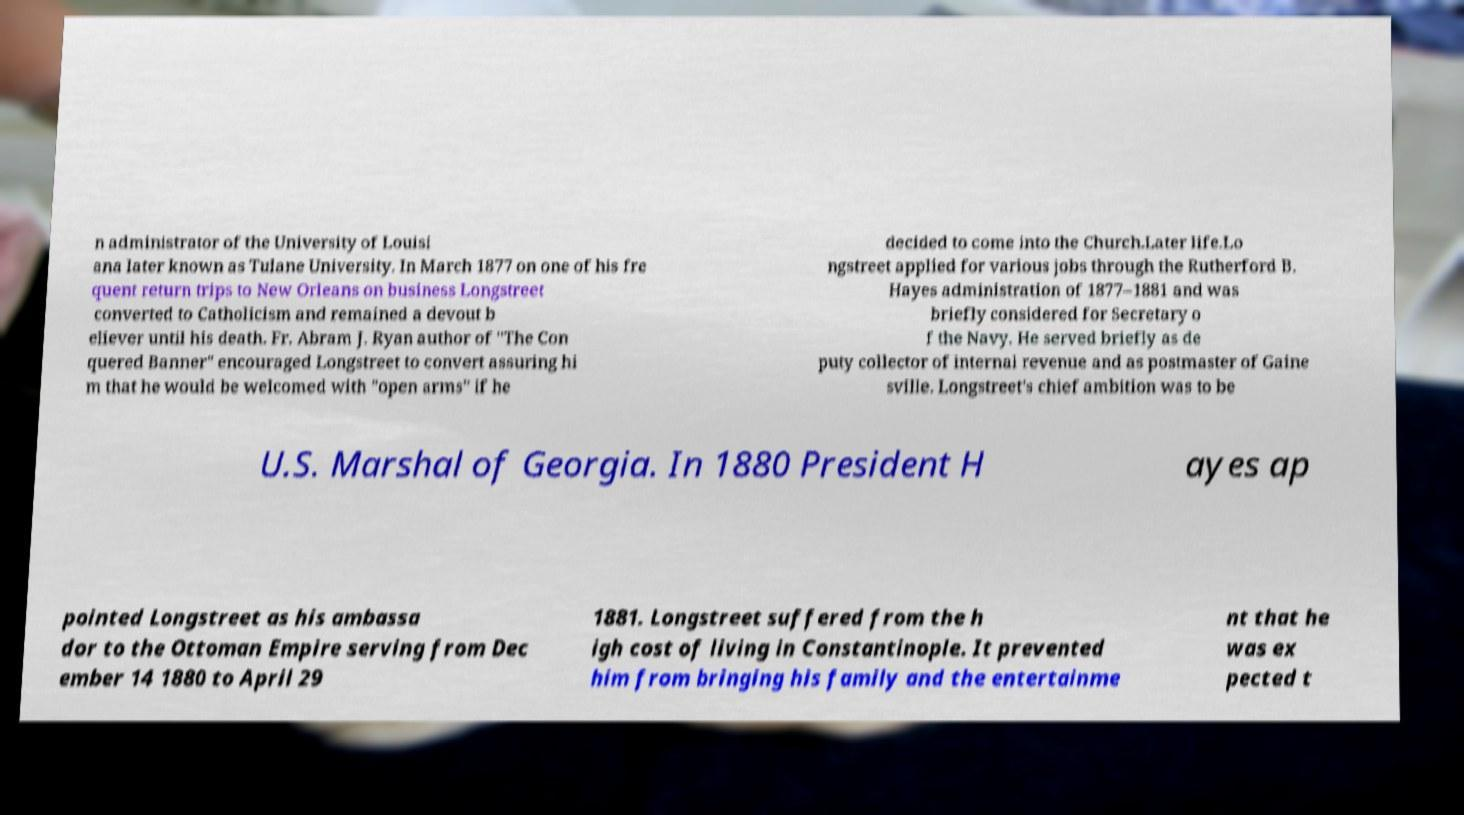What messages or text are displayed in this image? I need them in a readable, typed format. n administrator of the University of Louisi ana later known as Tulane University. In March 1877 on one of his fre quent return trips to New Orleans on business Longstreet converted to Catholicism and remained a devout b eliever until his death. Fr. Abram J. Ryan author of "The Con quered Banner" encouraged Longstreet to convert assuring hi m that he would be welcomed with "open arms" if he decided to come into the Church.Later life.Lo ngstreet applied for various jobs through the Rutherford B. Hayes administration of 1877–1881 and was briefly considered for Secretary o f the Navy. He served briefly as de puty collector of internal revenue and as postmaster of Gaine sville. Longstreet's chief ambition was to be U.S. Marshal of Georgia. In 1880 President H ayes ap pointed Longstreet as his ambassa dor to the Ottoman Empire serving from Dec ember 14 1880 to April 29 1881. Longstreet suffered from the h igh cost of living in Constantinople. It prevented him from bringing his family and the entertainme nt that he was ex pected t 